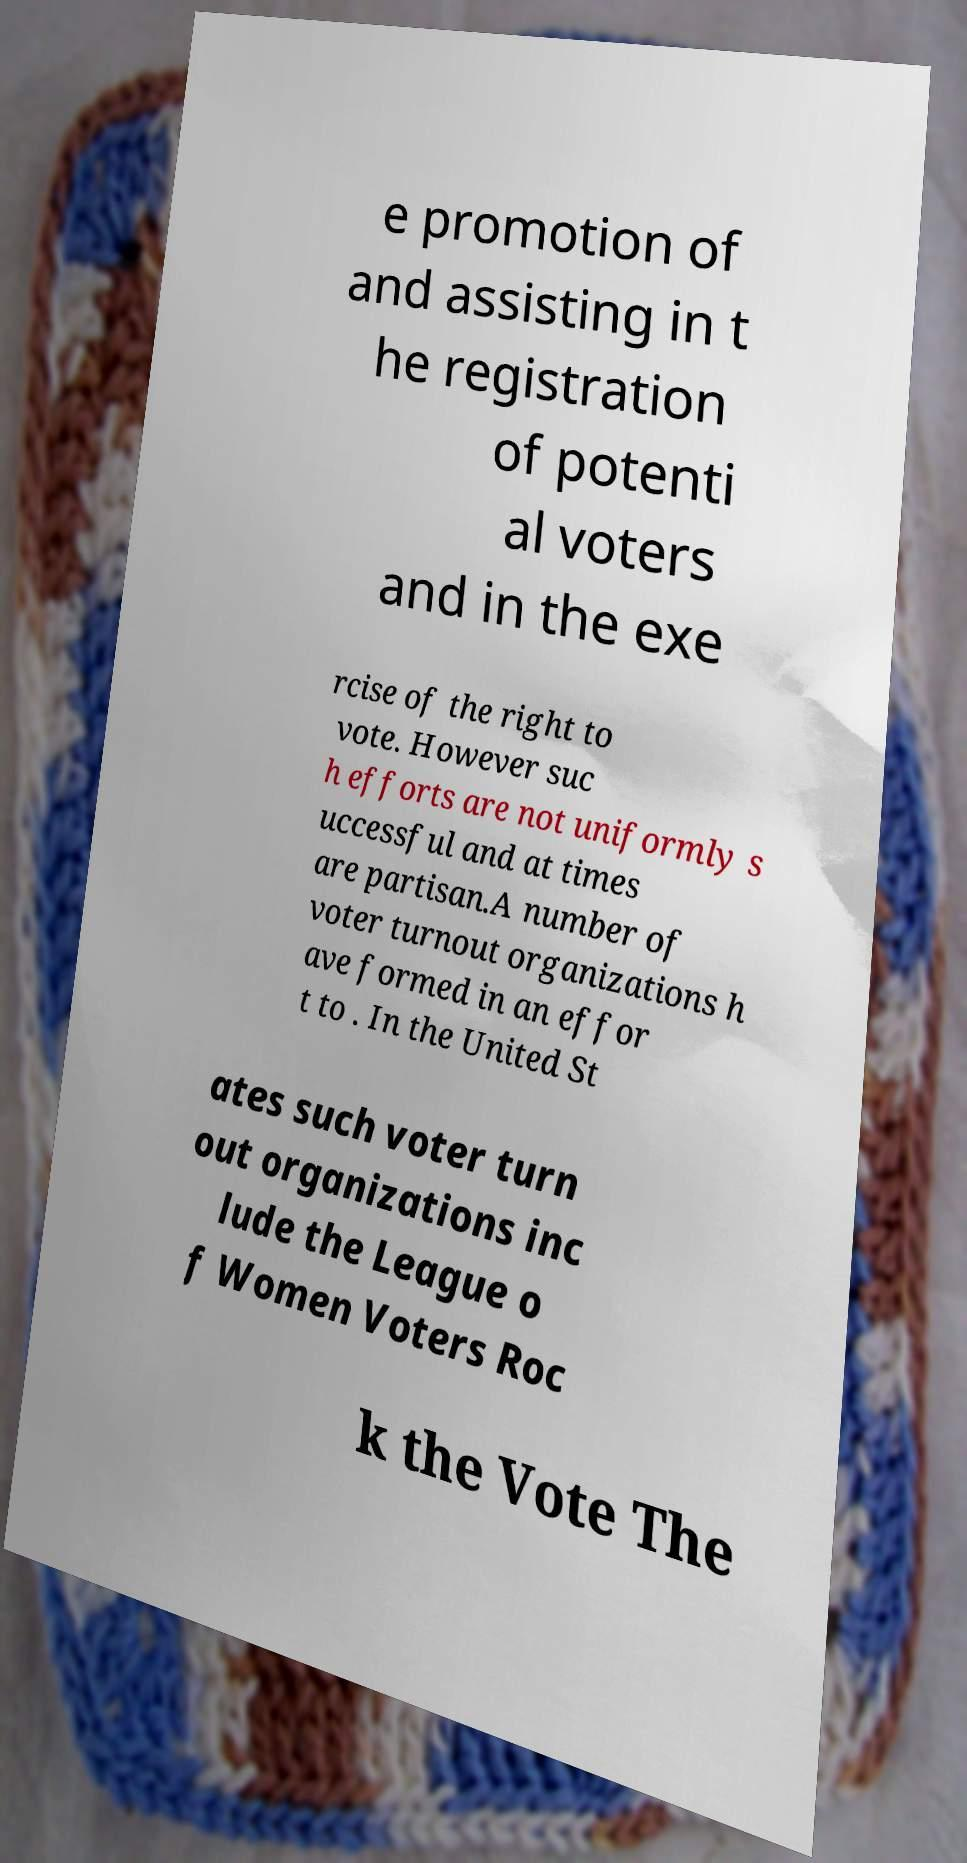What messages or text are displayed in this image? I need them in a readable, typed format. e promotion of and assisting in t he registration of potenti al voters and in the exe rcise of the right to vote. However suc h efforts are not uniformly s uccessful and at times are partisan.A number of voter turnout organizations h ave formed in an effor t to . In the United St ates such voter turn out organizations inc lude the League o f Women Voters Roc k the Vote The 